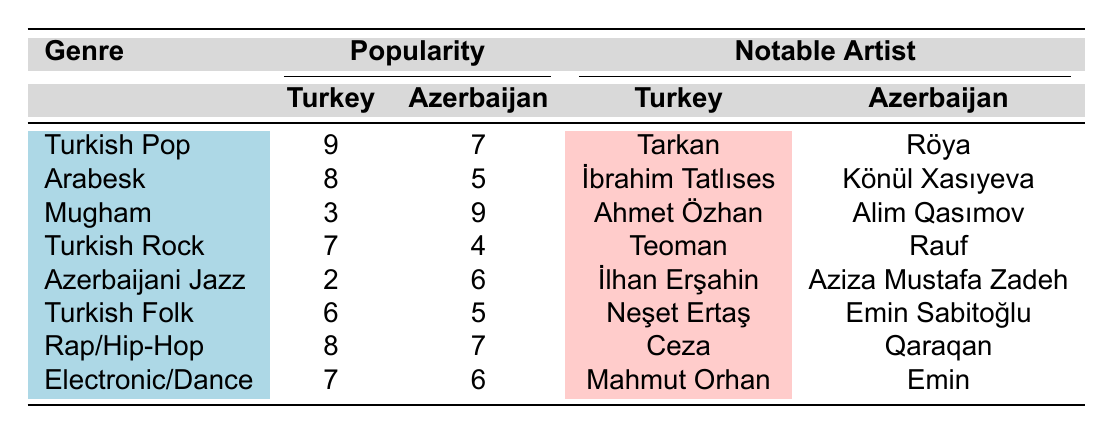What is the popularity of Turkish Rock in Turkey? The table indicates that the popularity of Turkish Rock in Turkey is represented by the value corresponding to this genre, which is 7.
Answer: 7 Which genre has the highest popularity in Azerbaijan? By comparing the popularity values for Azerbaijan in the table, Mugham has the highest score of 9.
Answer: Mugham Is Turkish Pop more popular in Turkey than in Azerbaijan? The popularity of Turkish Pop in Turkey is 9, while in Azerbaijan, it is 7. Since 9 is greater than 7, it is indeed more popular in Turkey.
Answer: Yes What is the difference in popularity between Arabesk in Turkey and Azerbaijan? The popularity of Arabesk in Turkey is 8, and in Azerbaijan, it is 5. To find the difference, we subtract these values: 8 - 5 = 3.
Answer: 3 Which notable Turkish artist corresponds to Azerbaijani Jazz? From the table, the notable artist for Azerbaijani Jazz in Turkey is İlhan Erşahin.
Answer: İlhan Erşahin What is the average popularity of the genres listed for Turkey? To find the average, we sum the popularity values for Turkey: 9 + 8 + 3 + 7 + 2 + 6 + 8 + 7 = 50. There are 8 genres, so we divide 50 by 8, which gives us 6.25.
Answer: 6.25 Does Mugham have a higher popularity in Azerbaijan compared to any other genre? The popularity of Mugham in Azerbaijan is 9, which is higher than the popularity of all other listed genres in Azerbaijan (highest being 7 for Rap/Hip-Hop).
Answer: Yes Which genre has the same level of popularity in both countries? Upon examining the table, Turkish Folk has a popularity of 6 in Turkey and 5 in Azerbaijan, which is the closest match, though not the same. Therefore, there is no genre with equal popularity.
Answer: None 